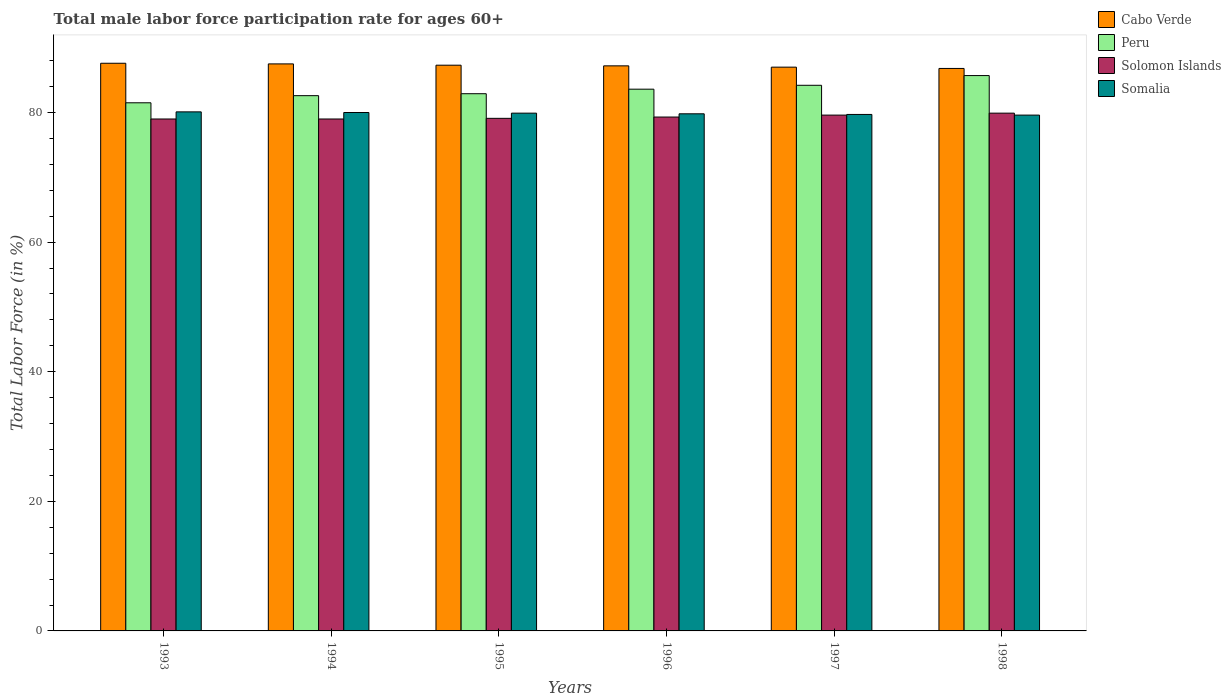What is the label of the 3rd group of bars from the left?
Give a very brief answer. 1995. In how many cases, is the number of bars for a given year not equal to the number of legend labels?
Your answer should be very brief. 0. What is the male labor force participation rate in Solomon Islands in 1994?
Give a very brief answer. 79. Across all years, what is the maximum male labor force participation rate in Solomon Islands?
Give a very brief answer. 79.9. Across all years, what is the minimum male labor force participation rate in Peru?
Keep it short and to the point. 81.5. In which year was the male labor force participation rate in Cabo Verde maximum?
Make the answer very short. 1993. In which year was the male labor force participation rate in Solomon Islands minimum?
Make the answer very short. 1993. What is the total male labor force participation rate in Solomon Islands in the graph?
Your response must be concise. 475.9. What is the difference between the male labor force participation rate in Cabo Verde in 1994 and that in 1998?
Provide a succinct answer. 0.7. What is the difference between the male labor force participation rate in Cabo Verde in 1993 and the male labor force participation rate in Solomon Islands in 1996?
Keep it short and to the point. 8.3. What is the average male labor force participation rate in Solomon Islands per year?
Offer a very short reply. 79.32. In the year 1997, what is the difference between the male labor force participation rate in Cabo Verde and male labor force participation rate in Solomon Islands?
Keep it short and to the point. 7.4. In how many years, is the male labor force participation rate in Somalia greater than 44 %?
Ensure brevity in your answer.  6. What is the ratio of the male labor force participation rate in Peru in 1994 to that in 1995?
Ensure brevity in your answer.  1. Is the male labor force participation rate in Cabo Verde in 1993 less than that in 1994?
Make the answer very short. No. What is the difference between the highest and the second highest male labor force participation rate in Peru?
Give a very brief answer. 1.5. What is the difference between the highest and the lowest male labor force participation rate in Cabo Verde?
Keep it short and to the point. 0.8. In how many years, is the male labor force participation rate in Somalia greater than the average male labor force participation rate in Somalia taken over all years?
Offer a terse response. 3. What does the 4th bar from the left in 1998 represents?
Your answer should be compact. Somalia. What does the 3rd bar from the right in 1996 represents?
Provide a succinct answer. Peru. Is it the case that in every year, the sum of the male labor force participation rate in Peru and male labor force participation rate in Somalia is greater than the male labor force participation rate in Solomon Islands?
Your answer should be compact. Yes. Are the values on the major ticks of Y-axis written in scientific E-notation?
Your answer should be very brief. No. Does the graph contain any zero values?
Provide a short and direct response. No. How are the legend labels stacked?
Provide a succinct answer. Vertical. What is the title of the graph?
Ensure brevity in your answer.  Total male labor force participation rate for ages 60+. Does "Turkmenistan" appear as one of the legend labels in the graph?
Keep it short and to the point. No. What is the label or title of the X-axis?
Offer a very short reply. Years. What is the Total Labor Force (in %) of Cabo Verde in 1993?
Offer a very short reply. 87.6. What is the Total Labor Force (in %) of Peru in 1993?
Your answer should be very brief. 81.5. What is the Total Labor Force (in %) of Solomon Islands in 1993?
Offer a very short reply. 79. What is the Total Labor Force (in %) in Somalia in 1993?
Offer a very short reply. 80.1. What is the Total Labor Force (in %) of Cabo Verde in 1994?
Your response must be concise. 87.5. What is the Total Labor Force (in %) of Peru in 1994?
Offer a very short reply. 82.6. What is the Total Labor Force (in %) of Solomon Islands in 1994?
Offer a very short reply. 79. What is the Total Labor Force (in %) in Somalia in 1994?
Provide a succinct answer. 80. What is the Total Labor Force (in %) in Cabo Verde in 1995?
Your answer should be very brief. 87.3. What is the Total Labor Force (in %) in Peru in 1995?
Give a very brief answer. 82.9. What is the Total Labor Force (in %) of Solomon Islands in 1995?
Ensure brevity in your answer.  79.1. What is the Total Labor Force (in %) of Somalia in 1995?
Your answer should be very brief. 79.9. What is the Total Labor Force (in %) in Cabo Verde in 1996?
Offer a terse response. 87.2. What is the Total Labor Force (in %) of Peru in 1996?
Offer a very short reply. 83.6. What is the Total Labor Force (in %) of Solomon Islands in 1996?
Your response must be concise. 79.3. What is the Total Labor Force (in %) of Somalia in 1996?
Make the answer very short. 79.8. What is the Total Labor Force (in %) in Peru in 1997?
Give a very brief answer. 84.2. What is the Total Labor Force (in %) in Solomon Islands in 1997?
Offer a very short reply. 79.6. What is the Total Labor Force (in %) in Somalia in 1997?
Provide a succinct answer. 79.7. What is the Total Labor Force (in %) of Cabo Verde in 1998?
Keep it short and to the point. 86.8. What is the Total Labor Force (in %) in Peru in 1998?
Ensure brevity in your answer.  85.7. What is the Total Labor Force (in %) of Solomon Islands in 1998?
Your answer should be very brief. 79.9. What is the Total Labor Force (in %) in Somalia in 1998?
Give a very brief answer. 79.6. Across all years, what is the maximum Total Labor Force (in %) of Cabo Verde?
Ensure brevity in your answer.  87.6. Across all years, what is the maximum Total Labor Force (in %) of Peru?
Keep it short and to the point. 85.7. Across all years, what is the maximum Total Labor Force (in %) of Solomon Islands?
Your answer should be very brief. 79.9. Across all years, what is the maximum Total Labor Force (in %) in Somalia?
Provide a succinct answer. 80.1. Across all years, what is the minimum Total Labor Force (in %) of Cabo Verde?
Your answer should be compact. 86.8. Across all years, what is the minimum Total Labor Force (in %) in Peru?
Give a very brief answer. 81.5. Across all years, what is the minimum Total Labor Force (in %) of Solomon Islands?
Provide a succinct answer. 79. Across all years, what is the minimum Total Labor Force (in %) in Somalia?
Make the answer very short. 79.6. What is the total Total Labor Force (in %) in Cabo Verde in the graph?
Your answer should be very brief. 523.4. What is the total Total Labor Force (in %) in Peru in the graph?
Keep it short and to the point. 500.5. What is the total Total Labor Force (in %) in Solomon Islands in the graph?
Your answer should be very brief. 475.9. What is the total Total Labor Force (in %) in Somalia in the graph?
Make the answer very short. 479.1. What is the difference between the Total Labor Force (in %) in Cabo Verde in 1993 and that in 1994?
Ensure brevity in your answer.  0.1. What is the difference between the Total Labor Force (in %) of Peru in 1993 and that in 1994?
Your answer should be very brief. -1.1. What is the difference between the Total Labor Force (in %) in Solomon Islands in 1993 and that in 1994?
Provide a succinct answer. 0. What is the difference between the Total Labor Force (in %) in Somalia in 1993 and that in 1995?
Your answer should be very brief. 0.2. What is the difference between the Total Labor Force (in %) in Cabo Verde in 1993 and that in 1996?
Offer a very short reply. 0.4. What is the difference between the Total Labor Force (in %) in Solomon Islands in 1993 and that in 1996?
Ensure brevity in your answer.  -0.3. What is the difference between the Total Labor Force (in %) of Solomon Islands in 1993 and that in 1997?
Provide a succinct answer. -0.6. What is the difference between the Total Labor Force (in %) of Peru in 1993 and that in 1998?
Make the answer very short. -4.2. What is the difference between the Total Labor Force (in %) of Somalia in 1993 and that in 1998?
Provide a short and direct response. 0.5. What is the difference between the Total Labor Force (in %) of Cabo Verde in 1994 and that in 1995?
Offer a terse response. 0.2. What is the difference between the Total Labor Force (in %) of Somalia in 1994 and that in 1995?
Your response must be concise. 0.1. What is the difference between the Total Labor Force (in %) in Somalia in 1994 and that in 1996?
Ensure brevity in your answer.  0.2. What is the difference between the Total Labor Force (in %) in Solomon Islands in 1994 and that in 1997?
Your response must be concise. -0.6. What is the difference between the Total Labor Force (in %) of Solomon Islands in 1994 and that in 1998?
Provide a short and direct response. -0.9. What is the difference between the Total Labor Force (in %) of Peru in 1995 and that in 1996?
Give a very brief answer. -0.7. What is the difference between the Total Labor Force (in %) in Solomon Islands in 1995 and that in 1996?
Make the answer very short. -0.2. What is the difference between the Total Labor Force (in %) in Peru in 1995 and that in 1997?
Give a very brief answer. -1.3. What is the difference between the Total Labor Force (in %) of Solomon Islands in 1995 and that in 1997?
Make the answer very short. -0.5. What is the difference between the Total Labor Force (in %) of Somalia in 1995 and that in 1997?
Provide a succinct answer. 0.2. What is the difference between the Total Labor Force (in %) of Solomon Islands in 1995 and that in 1998?
Your response must be concise. -0.8. What is the difference between the Total Labor Force (in %) in Somalia in 1995 and that in 1998?
Offer a terse response. 0.3. What is the difference between the Total Labor Force (in %) in Cabo Verde in 1996 and that in 1997?
Give a very brief answer. 0.2. What is the difference between the Total Labor Force (in %) of Solomon Islands in 1996 and that in 1997?
Your answer should be compact. -0.3. What is the difference between the Total Labor Force (in %) in Somalia in 1996 and that in 1997?
Your response must be concise. 0.1. What is the difference between the Total Labor Force (in %) in Peru in 1996 and that in 1998?
Offer a terse response. -2.1. What is the difference between the Total Labor Force (in %) of Peru in 1997 and that in 1998?
Ensure brevity in your answer.  -1.5. What is the difference between the Total Labor Force (in %) of Solomon Islands in 1997 and that in 1998?
Your response must be concise. -0.3. What is the difference between the Total Labor Force (in %) of Cabo Verde in 1993 and the Total Labor Force (in %) of Peru in 1994?
Offer a very short reply. 5. What is the difference between the Total Labor Force (in %) in Cabo Verde in 1993 and the Total Labor Force (in %) in Solomon Islands in 1994?
Make the answer very short. 8.6. What is the difference between the Total Labor Force (in %) of Cabo Verde in 1993 and the Total Labor Force (in %) of Somalia in 1994?
Provide a succinct answer. 7.6. What is the difference between the Total Labor Force (in %) in Peru in 1993 and the Total Labor Force (in %) in Solomon Islands in 1994?
Offer a very short reply. 2.5. What is the difference between the Total Labor Force (in %) of Peru in 1993 and the Total Labor Force (in %) of Somalia in 1995?
Provide a short and direct response. 1.6. What is the difference between the Total Labor Force (in %) of Cabo Verde in 1993 and the Total Labor Force (in %) of Peru in 1996?
Ensure brevity in your answer.  4. What is the difference between the Total Labor Force (in %) of Cabo Verde in 1993 and the Total Labor Force (in %) of Solomon Islands in 1996?
Ensure brevity in your answer.  8.3. What is the difference between the Total Labor Force (in %) of Peru in 1993 and the Total Labor Force (in %) of Solomon Islands in 1996?
Your response must be concise. 2.2. What is the difference between the Total Labor Force (in %) in Peru in 1993 and the Total Labor Force (in %) in Somalia in 1996?
Your response must be concise. 1.7. What is the difference between the Total Labor Force (in %) in Cabo Verde in 1993 and the Total Labor Force (in %) in Somalia in 1997?
Keep it short and to the point. 7.9. What is the difference between the Total Labor Force (in %) of Peru in 1993 and the Total Labor Force (in %) of Solomon Islands in 1997?
Provide a short and direct response. 1.9. What is the difference between the Total Labor Force (in %) of Peru in 1993 and the Total Labor Force (in %) of Somalia in 1997?
Your answer should be very brief. 1.8. What is the difference between the Total Labor Force (in %) of Cabo Verde in 1993 and the Total Labor Force (in %) of Peru in 1998?
Your answer should be very brief. 1.9. What is the difference between the Total Labor Force (in %) of Cabo Verde in 1994 and the Total Labor Force (in %) of Somalia in 1995?
Keep it short and to the point. 7.6. What is the difference between the Total Labor Force (in %) of Cabo Verde in 1994 and the Total Labor Force (in %) of Peru in 1996?
Make the answer very short. 3.9. What is the difference between the Total Labor Force (in %) of Cabo Verde in 1994 and the Total Labor Force (in %) of Solomon Islands in 1996?
Your answer should be compact. 8.2. What is the difference between the Total Labor Force (in %) of Cabo Verde in 1994 and the Total Labor Force (in %) of Somalia in 1996?
Provide a succinct answer. 7.7. What is the difference between the Total Labor Force (in %) in Peru in 1994 and the Total Labor Force (in %) in Somalia in 1996?
Provide a succinct answer. 2.8. What is the difference between the Total Labor Force (in %) of Cabo Verde in 1994 and the Total Labor Force (in %) of Solomon Islands in 1997?
Ensure brevity in your answer.  7.9. What is the difference between the Total Labor Force (in %) in Peru in 1994 and the Total Labor Force (in %) in Solomon Islands in 1997?
Make the answer very short. 3. What is the difference between the Total Labor Force (in %) of Cabo Verde in 1994 and the Total Labor Force (in %) of Solomon Islands in 1998?
Offer a terse response. 7.6. What is the difference between the Total Labor Force (in %) in Peru in 1994 and the Total Labor Force (in %) in Somalia in 1998?
Provide a short and direct response. 3. What is the difference between the Total Labor Force (in %) of Solomon Islands in 1994 and the Total Labor Force (in %) of Somalia in 1998?
Offer a very short reply. -0.6. What is the difference between the Total Labor Force (in %) of Cabo Verde in 1995 and the Total Labor Force (in %) of Peru in 1996?
Your answer should be very brief. 3.7. What is the difference between the Total Labor Force (in %) of Cabo Verde in 1995 and the Total Labor Force (in %) of Somalia in 1996?
Keep it short and to the point. 7.5. What is the difference between the Total Labor Force (in %) of Peru in 1995 and the Total Labor Force (in %) of Solomon Islands in 1996?
Your answer should be very brief. 3.6. What is the difference between the Total Labor Force (in %) in Peru in 1995 and the Total Labor Force (in %) in Somalia in 1996?
Your response must be concise. 3.1. What is the difference between the Total Labor Force (in %) in Solomon Islands in 1995 and the Total Labor Force (in %) in Somalia in 1996?
Provide a succinct answer. -0.7. What is the difference between the Total Labor Force (in %) of Cabo Verde in 1995 and the Total Labor Force (in %) of Solomon Islands in 1997?
Ensure brevity in your answer.  7.7. What is the difference between the Total Labor Force (in %) of Cabo Verde in 1995 and the Total Labor Force (in %) of Solomon Islands in 1998?
Make the answer very short. 7.4. What is the difference between the Total Labor Force (in %) in Cabo Verde in 1995 and the Total Labor Force (in %) in Somalia in 1998?
Your answer should be compact. 7.7. What is the difference between the Total Labor Force (in %) of Peru in 1995 and the Total Labor Force (in %) of Solomon Islands in 1998?
Your response must be concise. 3. What is the difference between the Total Labor Force (in %) of Peru in 1995 and the Total Labor Force (in %) of Somalia in 1998?
Keep it short and to the point. 3.3. What is the difference between the Total Labor Force (in %) in Solomon Islands in 1995 and the Total Labor Force (in %) in Somalia in 1998?
Your answer should be compact. -0.5. What is the difference between the Total Labor Force (in %) of Cabo Verde in 1996 and the Total Labor Force (in %) of Peru in 1997?
Provide a short and direct response. 3. What is the difference between the Total Labor Force (in %) of Cabo Verde in 1996 and the Total Labor Force (in %) of Solomon Islands in 1997?
Ensure brevity in your answer.  7.6. What is the difference between the Total Labor Force (in %) in Cabo Verde in 1996 and the Total Labor Force (in %) in Somalia in 1997?
Provide a short and direct response. 7.5. What is the difference between the Total Labor Force (in %) of Peru in 1996 and the Total Labor Force (in %) of Solomon Islands in 1997?
Provide a succinct answer. 4. What is the difference between the Total Labor Force (in %) in Peru in 1996 and the Total Labor Force (in %) in Somalia in 1997?
Your answer should be very brief. 3.9. What is the difference between the Total Labor Force (in %) in Solomon Islands in 1996 and the Total Labor Force (in %) in Somalia in 1997?
Provide a succinct answer. -0.4. What is the difference between the Total Labor Force (in %) of Peru in 1996 and the Total Labor Force (in %) of Solomon Islands in 1998?
Ensure brevity in your answer.  3.7. What is the difference between the Total Labor Force (in %) of Cabo Verde in 1997 and the Total Labor Force (in %) of Peru in 1998?
Provide a succinct answer. 1.3. What is the average Total Labor Force (in %) in Cabo Verde per year?
Your answer should be very brief. 87.23. What is the average Total Labor Force (in %) in Peru per year?
Your response must be concise. 83.42. What is the average Total Labor Force (in %) of Solomon Islands per year?
Make the answer very short. 79.32. What is the average Total Labor Force (in %) of Somalia per year?
Make the answer very short. 79.85. In the year 1993, what is the difference between the Total Labor Force (in %) in Cabo Verde and Total Labor Force (in %) in Peru?
Give a very brief answer. 6.1. In the year 1993, what is the difference between the Total Labor Force (in %) of Cabo Verde and Total Labor Force (in %) of Solomon Islands?
Offer a terse response. 8.6. In the year 1993, what is the difference between the Total Labor Force (in %) in Cabo Verde and Total Labor Force (in %) in Somalia?
Offer a very short reply. 7.5. In the year 1993, what is the difference between the Total Labor Force (in %) in Peru and Total Labor Force (in %) in Solomon Islands?
Offer a very short reply. 2.5. In the year 1994, what is the difference between the Total Labor Force (in %) of Cabo Verde and Total Labor Force (in %) of Peru?
Make the answer very short. 4.9. In the year 1994, what is the difference between the Total Labor Force (in %) in Cabo Verde and Total Labor Force (in %) in Somalia?
Ensure brevity in your answer.  7.5. In the year 1994, what is the difference between the Total Labor Force (in %) in Peru and Total Labor Force (in %) in Solomon Islands?
Keep it short and to the point. 3.6. In the year 1994, what is the difference between the Total Labor Force (in %) of Peru and Total Labor Force (in %) of Somalia?
Offer a terse response. 2.6. In the year 1994, what is the difference between the Total Labor Force (in %) of Solomon Islands and Total Labor Force (in %) of Somalia?
Give a very brief answer. -1. In the year 1995, what is the difference between the Total Labor Force (in %) of Cabo Verde and Total Labor Force (in %) of Peru?
Your response must be concise. 4.4. In the year 1995, what is the difference between the Total Labor Force (in %) in Cabo Verde and Total Labor Force (in %) in Solomon Islands?
Offer a terse response. 8.2. In the year 1996, what is the difference between the Total Labor Force (in %) in Cabo Verde and Total Labor Force (in %) in Peru?
Offer a terse response. 3.6. In the year 1996, what is the difference between the Total Labor Force (in %) of Cabo Verde and Total Labor Force (in %) of Solomon Islands?
Provide a short and direct response. 7.9. In the year 1996, what is the difference between the Total Labor Force (in %) in Cabo Verde and Total Labor Force (in %) in Somalia?
Offer a terse response. 7.4. In the year 1996, what is the difference between the Total Labor Force (in %) in Peru and Total Labor Force (in %) in Solomon Islands?
Ensure brevity in your answer.  4.3. In the year 1997, what is the difference between the Total Labor Force (in %) of Cabo Verde and Total Labor Force (in %) of Solomon Islands?
Make the answer very short. 7.4. In the year 1997, what is the difference between the Total Labor Force (in %) in Cabo Verde and Total Labor Force (in %) in Somalia?
Your answer should be compact. 7.3. In the year 1997, what is the difference between the Total Labor Force (in %) of Solomon Islands and Total Labor Force (in %) of Somalia?
Provide a succinct answer. -0.1. What is the ratio of the Total Labor Force (in %) of Cabo Verde in 1993 to that in 1994?
Your response must be concise. 1. What is the ratio of the Total Labor Force (in %) in Peru in 1993 to that in 1994?
Provide a succinct answer. 0.99. What is the ratio of the Total Labor Force (in %) of Solomon Islands in 1993 to that in 1994?
Ensure brevity in your answer.  1. What is the ratio of the Total Labor Force (in %) in Peru in 1993 to that in 1995?
Give a very brief answer. 0.98. What is the ratio of the Total Labor Force (in %) of Solomon Islands in 1993 to that in 1995?
Provide a short and direct response. 1. What is the ratio of the Total Labor Force (in %) of Peru in 1993 to that in 1996?
Your answer should be compact. 0.97. What is the ratio of the Total Labor Force (in %) of Somalia in 1993 to that in 1996?
Provide a succinct answer. 1. What is the ratio of the Total Labor Force (in %) of Peru in 1993 to that in 1997?
Make the answer very short. 0.97. What is the ratio of the Total Labor Force (in %) of Solomon Islands in 1993 to that in 1997?
Give a very brief answer. 0.99. What is the ratio of the Total Labor Force (in %) in Cabo Verde in 1993 to that in 1998?
Provide a short and direct response. 1.01. What is the ratio of the Total Labor Force (in %) of Peru in 1993 to that in 1998?
Ensure brevity in your answer.  0.95. What is the ratio of the Total Labor Force (in %) of Solomon Islands in 1993 to that in 1998?
Make the answer very short. 0.99. What is the ratio of the Total Labor Force (in %) of Somalia in 1993 to that in 1998?
Provide a succinct answer. 1.01. What is the ratio of the Total Labor Force (in %) in Peru in 1994 to that in 1995?
Make the answer very short. 1. What is the ratio of the Total Labor Force (in %) in Somalia in 1994 to that in 1995?
Ensure brevity in your answer.  1. What is the ratio of the Total Labor Force (in %) of Solomon Islands in 1994 to that in 1996?
Keep it short and to the point. 1. What is the ratio of the Total Labor Force (in %) in Somalia in 1994 to that in 1996?
Keep it short and to the point. 1. What is the ratio of the Total Labor Force (in %) of Peru in 1994 to that in 1997?
Give a very brief answer. 0.98. What is the ratio of the Total Labor Force (in %) in Solomon Islands in 1994 to that in 1997?
Your answer should be compact. 0.99. What is the ratio of the Total Labor Force (in %) of Somalia in 1994 to that in 1997?
Provide a short and direct response. 1. What is the ratio of the Total Labor Force (in %) of Cabo Verde in 1994 to that in 1998?
Your answer should be very brief. 1.01. What is the ratio of the Total Labor Force (in %) in Peru in 1994 to that in 1998?
Offer a very short reply. 0.96. What is the ratio of the Total Labor Force (in %) in Solomon Islands in 1994 to that in 1998?
Give a very brief answer. 0.99. What is the ratio of the Total Labor Force (in %) of Cabo Verde in 1995 to that in 1996?
Keep it short and to the point. 1. What is the ratio of the Total Labor Force (in %) of Solomon Islands in 1995 to that in 1996?
Keep it short and to the point. 1. What is the ratio of the Total Labor Force (in %) in Somalia in 1995 to that in 1996?
Provide a short and direct response. 1. What is the ratio of the Total Labor Force (in %) in Peru in 1995 to that in 1997?
Give a very brief answer. 0.98. What is the ratio of the Total Labor Force (in %) of Cabo Verde in 1995 to that in 1998?
Ensure brevity in your answer.  1.01. What is the ratio of the Total Labor Force (in %) in Peru in 1995 to that in 1998?
Your answer should be compact. 0.97. What is the ratio of the Total Labor Force (in %) in Solomon Islands in 1995 to that in 1998?
Offer a very short reply. 0.99. What is the ratio of the Total Labor Force (in %) of Somalia in 1995 to that in 1998?
Provide a succinct answer. 1. What is the ratio of the Total Labor Force (in %) of Cabo Verde in 1996 to that in 1997?
Your answer should be very brief. 1. What is the ratio of the Total Labor Force (in %) of Peru in 1996 to that in 1997?
Your response must be concise. 0.99. What is the ratio of the Total Labor Force (in %) of Cabo Verde in 1996 to that in 1998?
Make the answer very short. 1. What is the ratio of the Total Labor Force (in %) of Peru in 1996 to that in 1998?
Provide a succinct answer. 0.98. What is the ratio of the Total Labor Force (in %) of Solomon Islands in 1996 to that in 1998?
Keep it short and to the point. 0.99. What is the ratio of the Total Labor Force (in %) in Somalia in 1996 to that in 1998?
Keep it short and to the point. 1. What is the ratio of the Total Labor Force (in %) in Cabo Verde in 1997 to that in 1998?
Your answer should be very brief. 1. What is the ratio of the Total Labor Force (in %) in Peru in 1997 to that in 1998?
Your response must be concise. 0.98. What is the ratio of the Total Labor Force (in %) of Somalia in 1997 to that in 1998?
Your response must be concise. 1. What is the difference between the highest and the second highest Total Labor Force (in %) of Cabo Verde?
Provide a succinct answer. 0.1. What is the difference between the highest and the second highest Total Labor Force (in %) in Solomon Islands?
Keep it short and to the point. 0.3. What is the difference between the highest and the second highest Total Labor Force (in %) in Somalia?
Ensure brevity in your answer.  0.1. What is the difference between the highest and the lowest Total Labor Force (in %) in Cabo Verde?
Provide a short and direct response. 0.8. What is the difference between the highest and the lowest Total Labor Force (in %) in Peru?
Provide a succinct answer. 4.2. What is the difference between the highest and the lowest Total Labor Force (in %) of Solomon Islands?
Provide a short and direct response. 0.9. What is the difference between the highest and the lowest Total Labor Force (in %) in Somalia?
Provide a short and direct response. 0.5. 